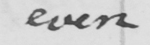Please provide the text content of this handwritten line. even 